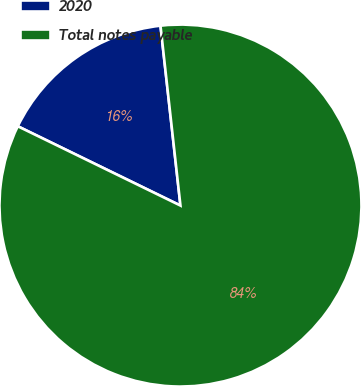<chart> <loc_0><loc_0><loc_500><loc_500><pie_chart><fcel>2020<fcel>Total notes payable<nl><fcel>16.02%<fcel>83.98%<nl></chart> 